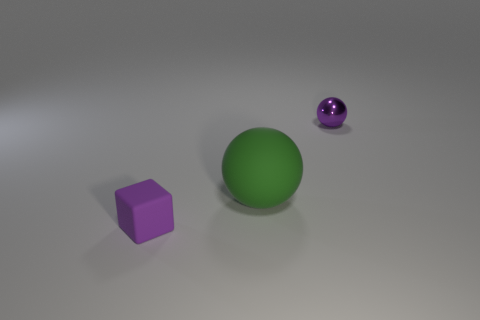Add 3 tiny purple shiny balls. How many objects exist? 6 Subtract all spheres. How many objects are left? 1 Subtract all tiny purple things. Subtract all purple metal things. How many objects are left? 0 Add 1 purple shiny balls. How many purple shiny balls are left? 2 Add 1 small purple rubber things. How many small purple rubber things exist? 2 Subtract 0 brown cylinders. How many objects are left? 3 